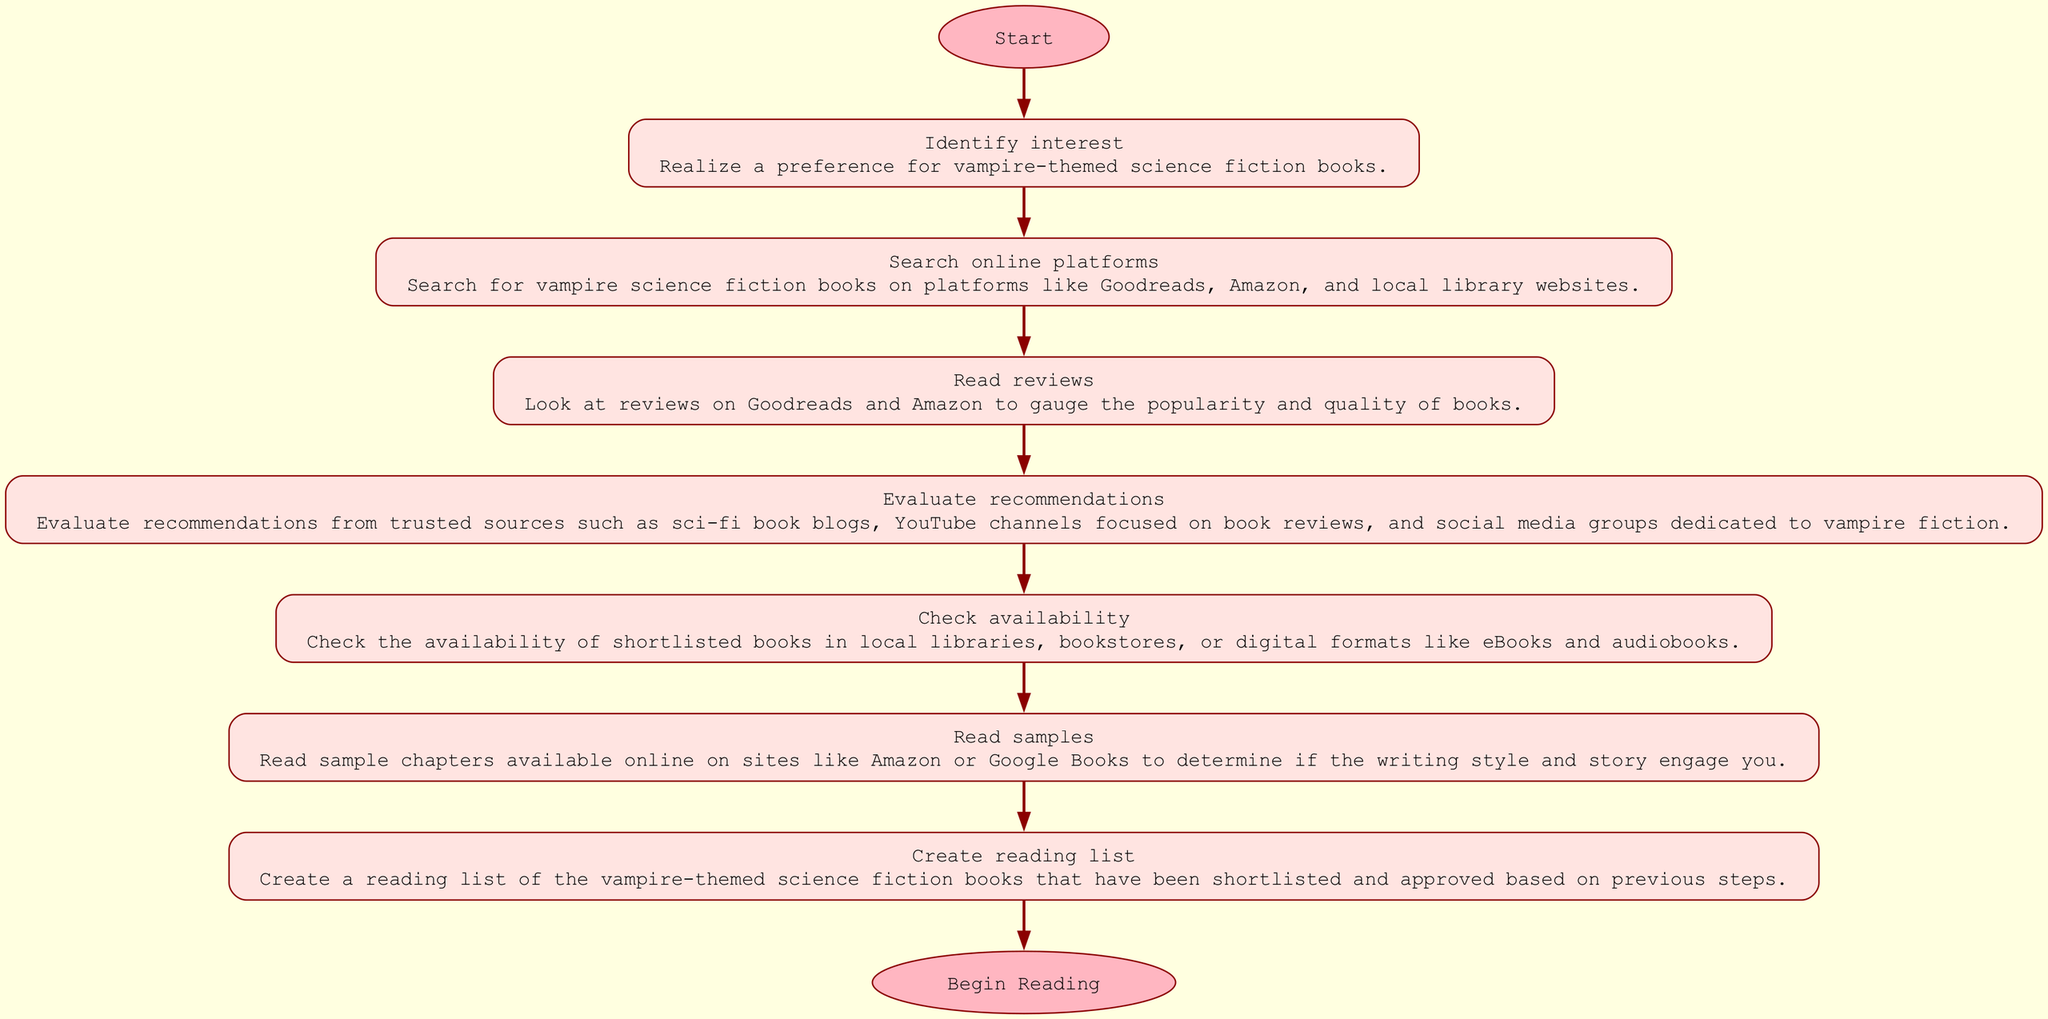What is the starting phase in the flow? The diagram indicates that the starting phase is titled "Identify_interest." This is the first step shown after the "Start" node.
Answer: Identify interest How many steps are there in this research process? Counting the individual phases listed in the diagram, there are seven steps before reaching the "Begin Reading" node.
Answer: Seven Which phase comes right after "Search online platforms"? The diagram shows that the phase immediately following "Search online platforms" is "Read reviews," connecting the two phases in sequence.
Answer: Read reviews What is the final phase before beginning to read? According to the diagram, the last phase listed before moving to "Begin Reading" is "Create reading list." This is the last action taken in the process.
Answer: Create reading list What type of sources are evaluated in the "Evaluate recommendations" phase? The diagram specifies that the recommendations are evaluated from trusted sources like sci-fi book blogs, YouTube channels, and social media groups dedicated to vampire fiction.
Answer: Trusted sources How does one check for the availability of books? The step titled "Check availability" describes checking local libraries, bookstores, or digital formats for the shortlisted books.
Answer: Local libraries, bookstores, digital formats What is the transition from the last step in the process? The last step "Create reading list" directly connects to the "End" node labeled "Begin Reading," indicating that after the reading list is created, the reader can start reading.
Answer: Begin Reading What are some digital formats to check for availability? The diagram notes that in the "Check availability" step, digital formats include eBooks and audiobooks, which are formats being searched for availability.
Answer: eBooks, audiobooks 